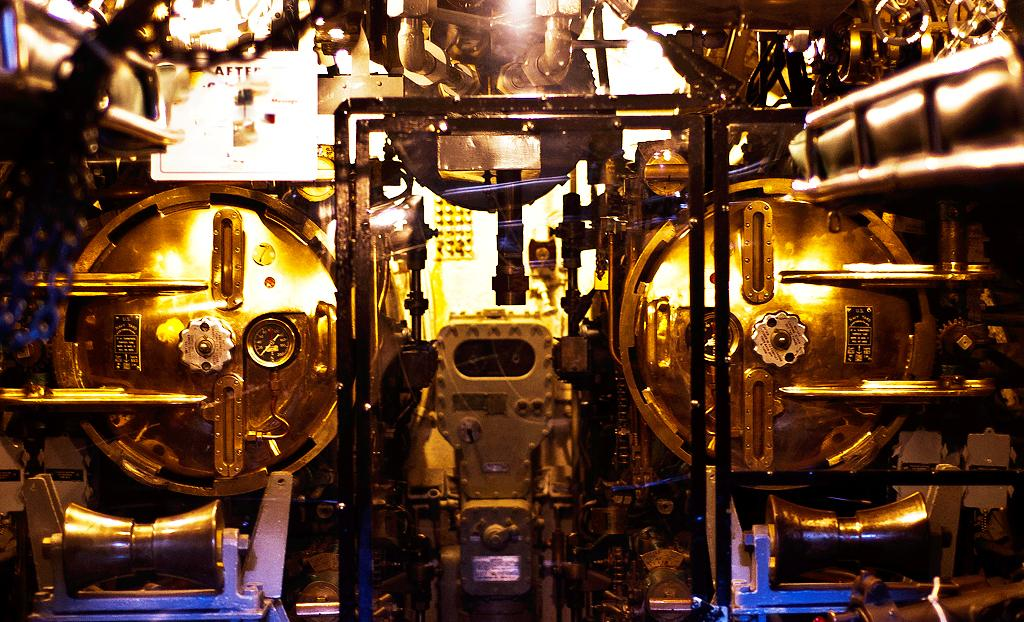What can be seen in the image? There are machines in the image. Can you describe any specific features of the machines? One of the machines has text on it. What type of cart is being used by the group of lawyers in the image? There is no group of lawyers or cart present in the image; it only features machines with text on them. 